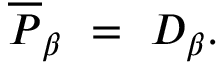Convert formula to latex. <formula><loc_0><loc_0><loc_500><loc_500>\overline { P } _ { \beta } = D _ { \beta } .</formula> 